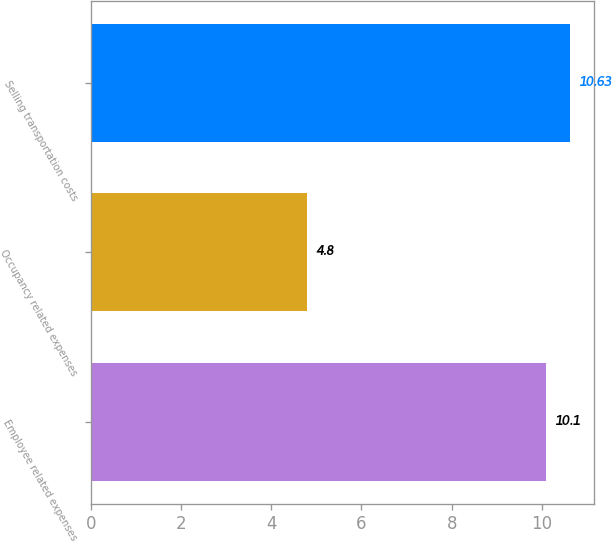<chart> <loc_0><loc_0><loc_500><loc_500><bar_chart><fcel>Employee related expenses<fcel>Occupancy related expenses<fcel>Selling transportation costs<nl><fcel>10.1<fcel>4.8<fcel>10.63<nl></chart> 